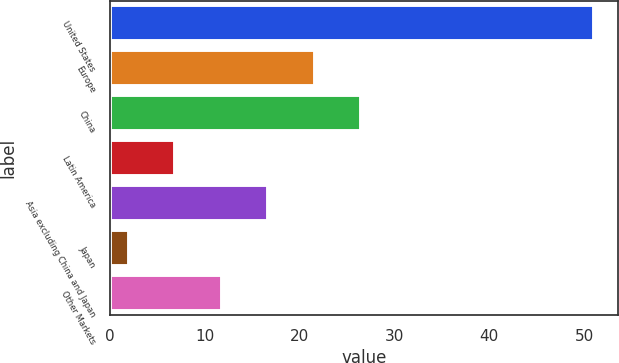Convert chart. <chart><loc_0><loc_0><loc_500><loc_500><bar_chart><fcel>United States<fcel>Europe<fcel>China<fcel>Latin America<fcel>Asia excluding China and Japan<fcel>Japan<fcel>Other Markets<nl><fcel>51<fcel>21.6<fcel>26.5<fcel>6.9<fcel>16.7<fcel>2<fcel>11.8<nl></chart> 